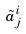<formula> <loc_0><loc_0><loc_500><loc_500>\tilde { a } _ { j } ^ { i }</formula> 